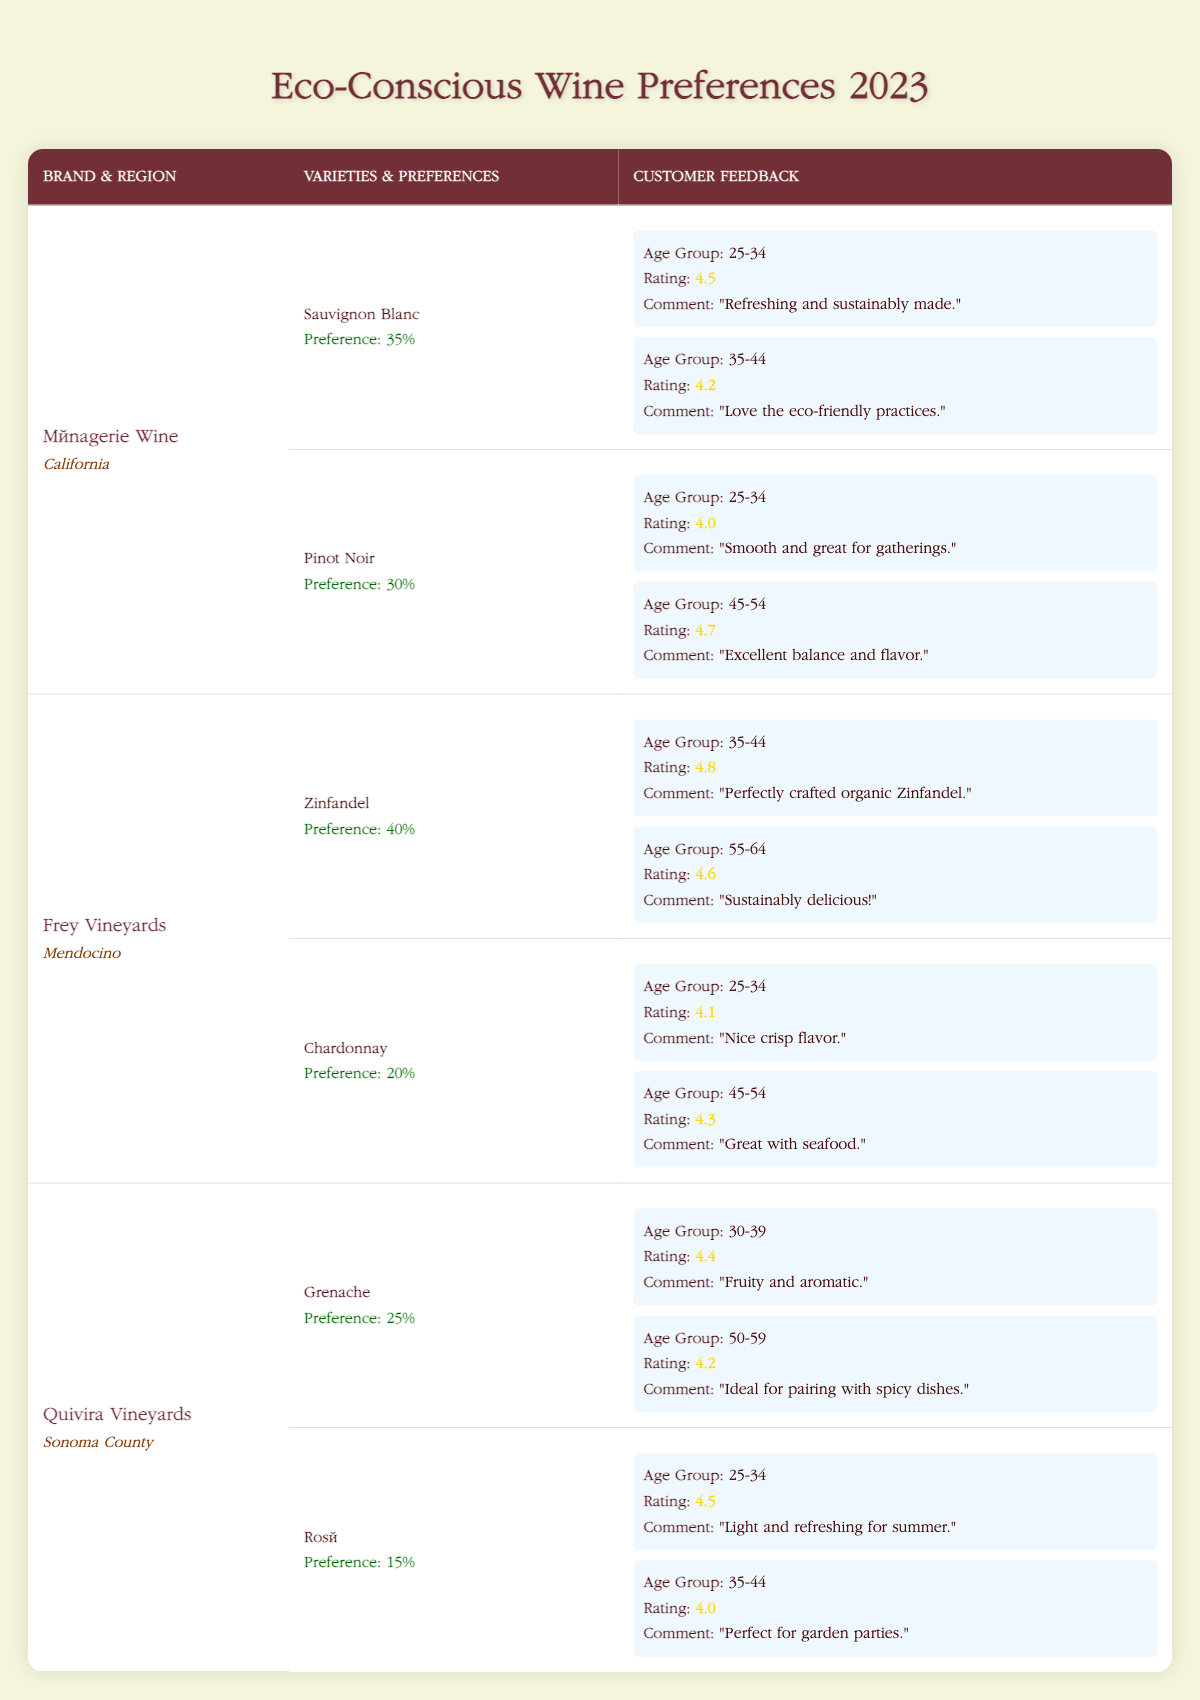What is the most preferred wine variety from Frey Vineyards? According to the table, Frey Vineyards has two varieties: Zinfandel with a customer preference percentage of 40% and Chardonnay with 20%. The highest percentage indicates that Zinfandel is the most preferred wine variety from this vineyard.
Answer: Zinfandel Which age group rated Ménagerie's Sauvignon Blanc the highest? The table shows that Ménagerie Wine's Sauvignon Blanc received feedback from two age groups: 25-34 with a rating of 4.5 and 35-44 with a rating of 4.2. Since 4.5 is higher than 4.2, the 25-34 age group rated it the highest.
Answer: 25-34 What is the combined customer preference percentage for Pinot Noir from Ménagerie Wine and Rosé from Quivira Vineyards? Ménagerie Wine's Pinot Noir has a customer preference percentage of 30%, while Quivira Vineyards' Rosé has a preference of 15%. To find the combined preference, add these percentages: 30% + 15% = 45%.
Answer: 45% Is the customer feedback for Frey Vineyards' Chardonnay more positive than for its Zinfandel? Frey Vineyards' Chardonnay ratings are 4.1 (age group 25-34) and 4.3 (age group 45-54), averaging to 4.2. For Zinfandel, the ratings are 4.8 (age group 35-44) and 4.6 (age group 55-64), averaging to 4.7. Since 4.2 is less than 4.7, the feedback for Chardonnay is not more positive.
Answer: No Which eco-conscious wine brand has the highest overall customer preference percentage? By reviewing the customer preference percentages of all the brands: Ménagerie Wine (35% + 30% = 65%), Frey Vineyards (40% + 20% = 60%), and Quivira Vineyards (25% + 15% = 40%). Ménagerie Wine has the highest overall percentage of 65%.
Answer: Ménagerie Wine 